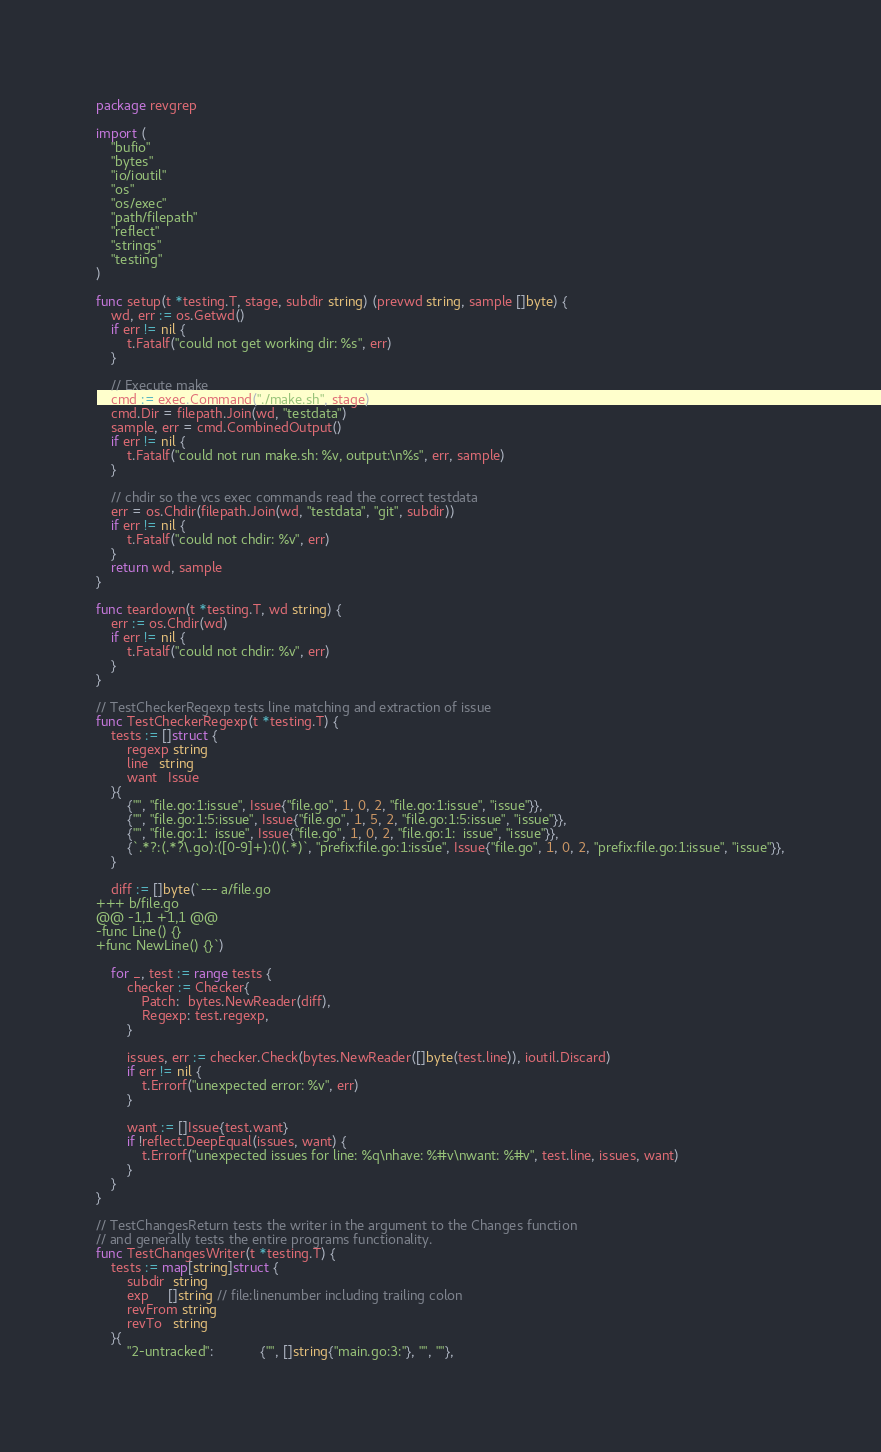Convert code to text. <code><loc_0><loc_0><loc_500><loc_500><_Go_>package revgrep

import (
	"bufio"
	"bytes"
	"io/ioutil"
	"os"
	"os/exec"
	"path/filepath"
	"reflect"
	"strings"
	"testing"
)

func setup(t *testing.T, stage, subdir string) (prevwd string, sample []byte) {
	wd, err := os.Getwd()
	if err != nil {
		t.Fatalf("could not get working dir: %s", err)
	}

	// Execute make
	cmd := exec.Command("./make.sh", stage)
	cmd.Dir = filepath.Join(wd, "testdata")
	sample, err = cmd.CombinedOutput()
	if err != nil {
		t.Fatalf("could not run make.sh: %v, output:\n%s", err, sample)
	}

	// chdir so the vcs exec commands read the correct testdata
	err = os.Chdir(filepath.Join(wd, "testdata", "git", subdir))
	if err != nil {
		t.Fatalf("could not chdir: %v", err)
	}
	return wd, sample
}

func teardown(t *testing.T, wd string) {
	err := os.Chdir(wd)
	if err != nil {
		t.Fatalf("could not chdir: %v", err)
	}
}

// TestCheckerRegexp tests line matching and extraction of issue
func TestCheckerRegexp(t *testing.T) {
	tests := []struct {
		regexp string
		line   string
		want   Issue
	}{
		{"", "file.go:1:issue", Issue{"file.go", 1, 0, 2, "file.go:1:issue", "issue"}},
		{"", "file.go:1:5:issue", Issue{"file.go", 1, 5, 2, "file.go:1:5:issue", "issue"}},
		{"", "file.go:1:  issue", Issue{"file.go", 1, 0, 2, "file.go:1:  issue", "issue"}},
		{`.*?:(.*?\.go):([0-9]+):()(.*)`, "prefix:file.go:1:issue", Issue{"file.go", 1, 0, 2, "prefix:file.go:1:issue", "issue"}},
	}

	diff := []byte(`--- a/file.go
+++ b/file.go
@@ -1,1 +1,1 @@
-func Line() {}
+func NewLine() {}`)

	for _, test := range tests {
		checker := Checker{
			Patch:  bytes.NewReader(diff),
			Regexp: test.regexp,
		}

		issues, err := checker.Check(bytes.NewReader([]byte(test.line)), ioutil.Discard)
		if err != nil {
			t.Errorf("unexpected error: %v", err)
		}

		want := []Issue{test.want}
		if !reflect.DeepEqual(issues, want) {
			t.Errorf("unexpected issues for line: %q\nhave: %#v\nwant: %#v", test.line, issues, want)
		}
	}
}

// TestChangesReturn tests the writer in the argument to the Changes function
// and generally tests the entire programs functionality.
func TestChangesWriter(t *testing.T) {
	tests := map[string]struct {
		subdir  string
		exp     []string // file:linenumber including trailing colon
		revFrom string
		revTo   string
	}{
		"2-untracked":            {"", []string{"main.go:3:"}, "", ""},</code> 